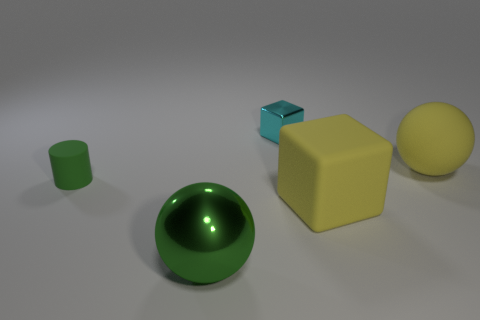Do the sphere that is left of the tiny metallic block and the cube in front of the cyan shiny cube have the same size?
Offer a very short reply. Yes. Are there any green matte objects of the same shape as the big green metallic object?
Offer a terse response. No. Are there fewer green cylinders that are to the right of the big metallic sphere than large spheres?
Offer a terse response. Yes. Is the cyan object the same shape as the big green metallic thing?
Keep it short and to the point. No. What is the size of the ball that is in front of the big yellow sphere?
Keep it short and to the point. Large. What size is the sphere that is made of the same material as the small cube?
Provide a succinct answer. Large. Are there fewer yellow matte things than big yellow matte cubes?
Your answer should be compact. No. There is a sphere that is the same size as the green shiny object; what is it made of?
Ensure brevity in your answer.  Rubber. Are there more green rubber cylinders than big purple blocks?
Your answer should be very brief. Yes. What number of other objects are there of the same color as the small metal block?
Your response must be concise. 0. 